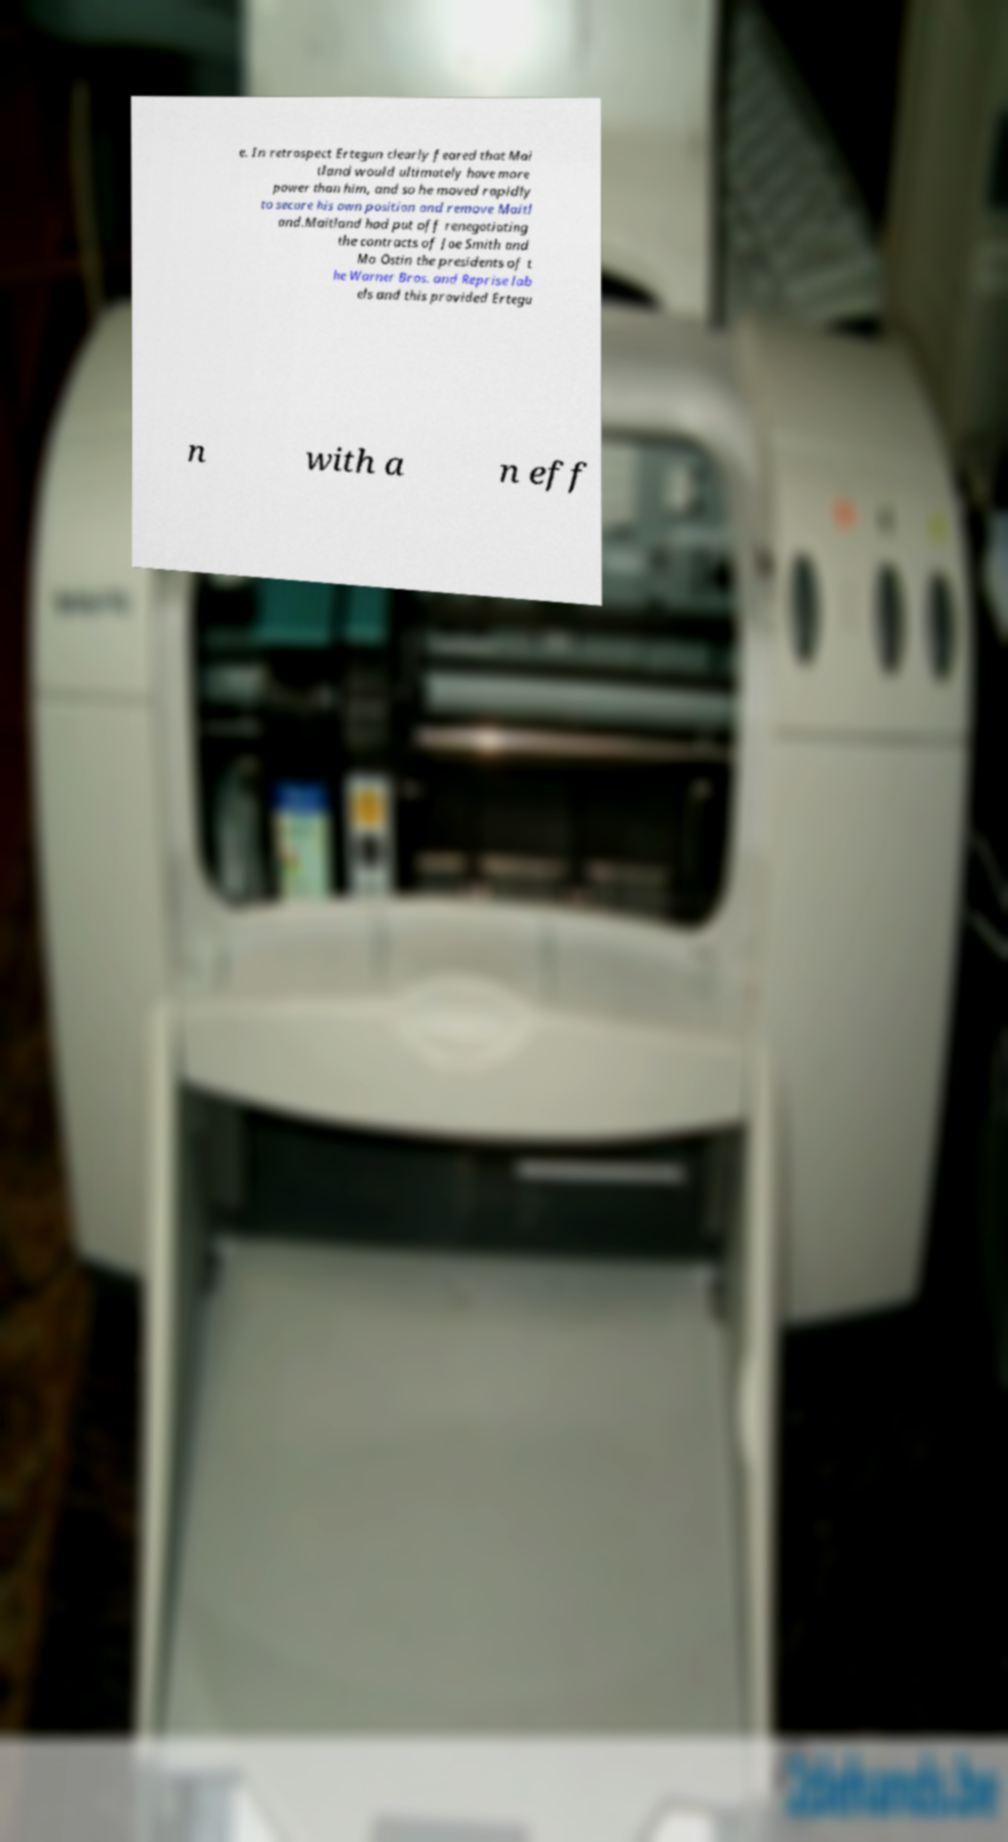There's text embedded in this image that I need extracted. Can you transcribe it verbatim? e. In retrospect Ertegun clearly feared that Mai tland would ultimately have more power than him, and so he moved rapidly to secure his own position and remove Maitl and.Maitland had put off renegotiating the contracts of Joe Smith and Mo Ostin the presidents of t he Warner Bros. and Reprise lab els and this provided Ertegu n with a n eff 